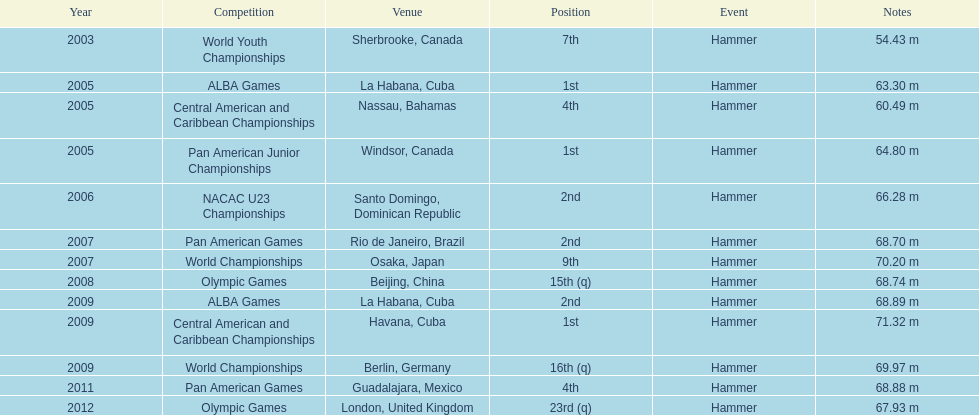Does arasay thondike have more/less than 4 1st place tournament finishes? Less. 